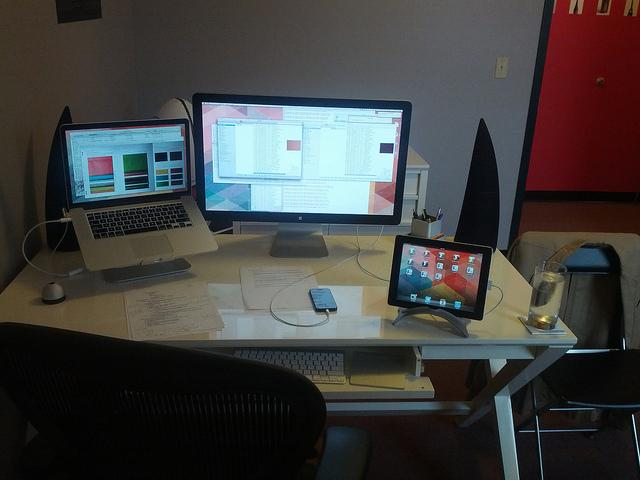What is on the table? computer 